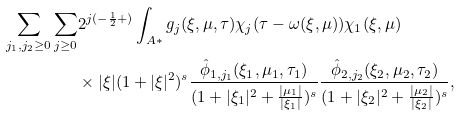<formula> <loc_0><loc_0><loc_500><loc_500>\sum _ { j _ { 1 } , j _ { 2 } \geq 0 } \sum _ { j \geq 0 } & 2 ^ { j ( - \frac { 1 } { 2 } + ) } \int _ { A * } g _ { j } ( \xi , \mu , \tau ) \chi _ { j } ( \tau - \omega ( \xi , \mu ) ) \chi _ { 1 } ( \xi , \mu ) \\ & \times | \xi | ( 1 + | \xi | ^ { 2 } ) ^ { s } \frac { \hat { \phi } _ { 1 , j _ { 1 } } ( \xi _ { 1 } , \mu _ { 1 } , \tau _ { 1 } ) } { ( 1 + | \xi _ { 1 } | ^ { 2 } + \frac { | \mu _ { 1 } | } { | \xi _ { 1 } | } ) ^ { s } } \frac { \hat { \phi } _ { 2 , j _ { 2 } } ( \xi _ { 2 } , \mu _ { 2 } , \tau _ { 2 } ) } { ( 1 + | \xi _ { 2 } | ^ { 2 } + \frac { | \mu _ { 2 } | } { | \xi _ { 2 } | } ) ^ { s } } ,</formula> 